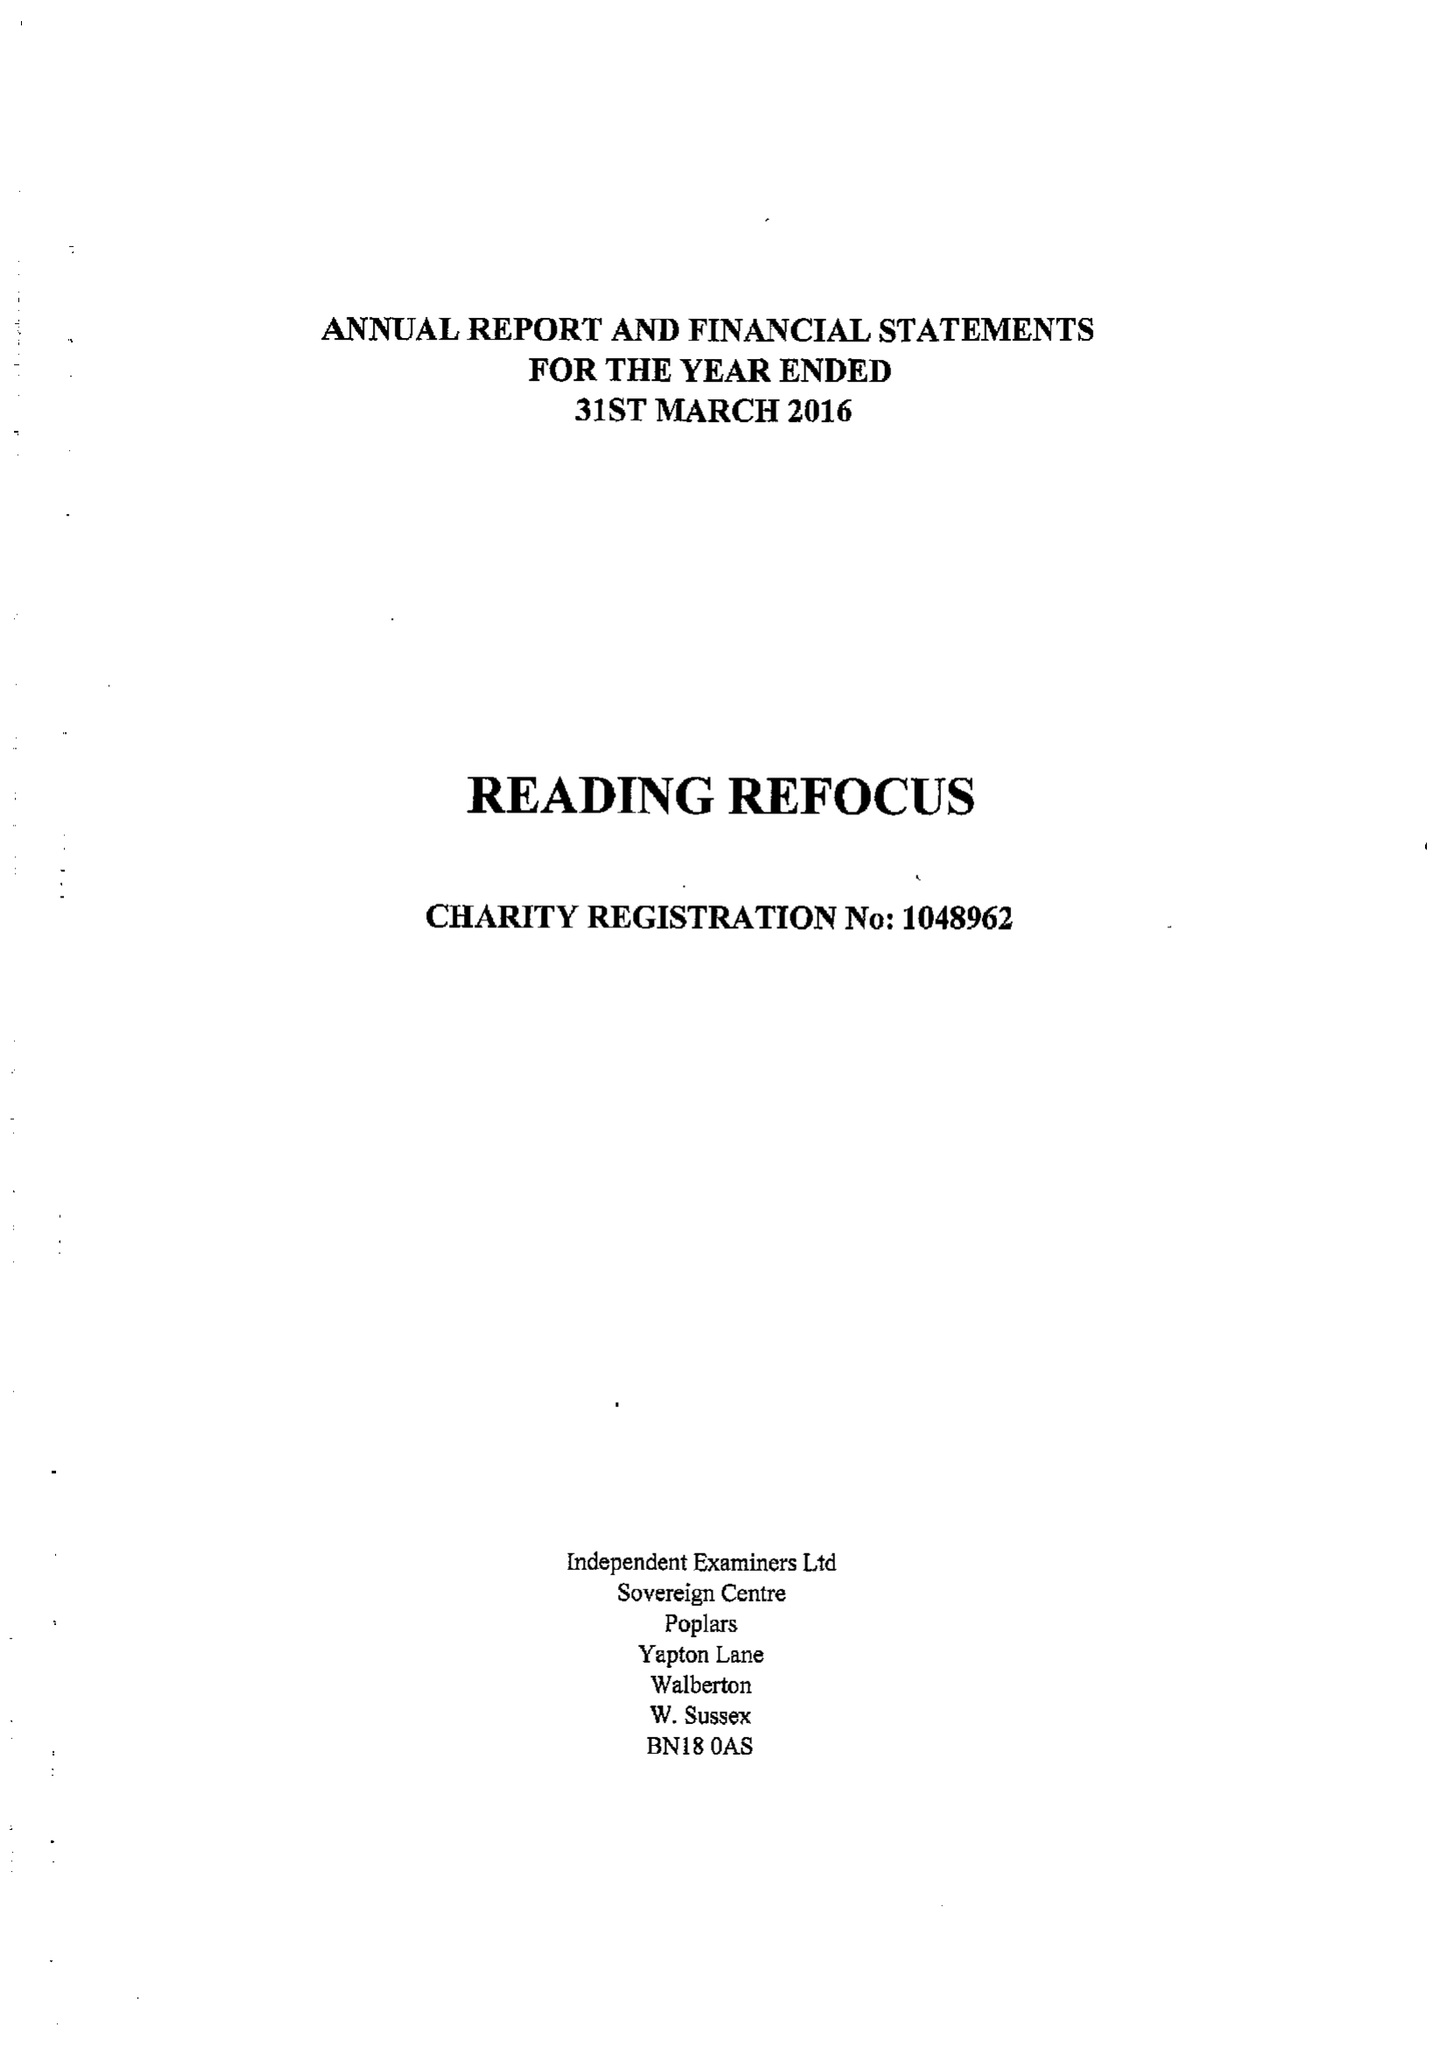What is the value for the address__post_town?
Answer the question using a single word or phrase. READING 